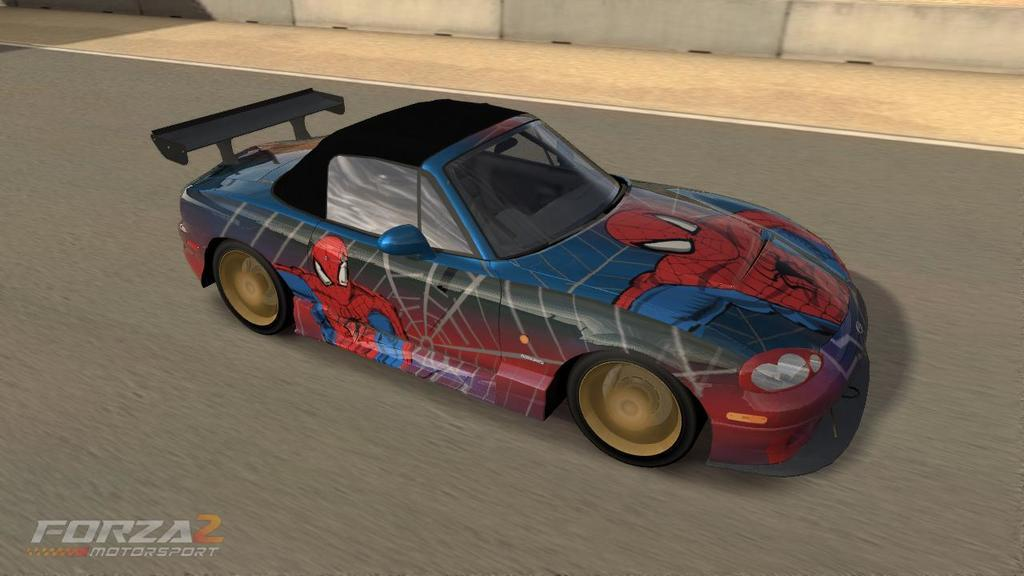What type of image is being described? The image is animated. What can be seen on the road in the image? There is a car on the road in the image. What is visible in the background of the image? There is a wall in the background of the image. Where is the text located in the image? The text is in the bottom left side of the image. Can you tell me what the spy is saying to the art in the image? There is no spy or art present in the image; it features an animated scene with a car on the road and a wall in the background. 